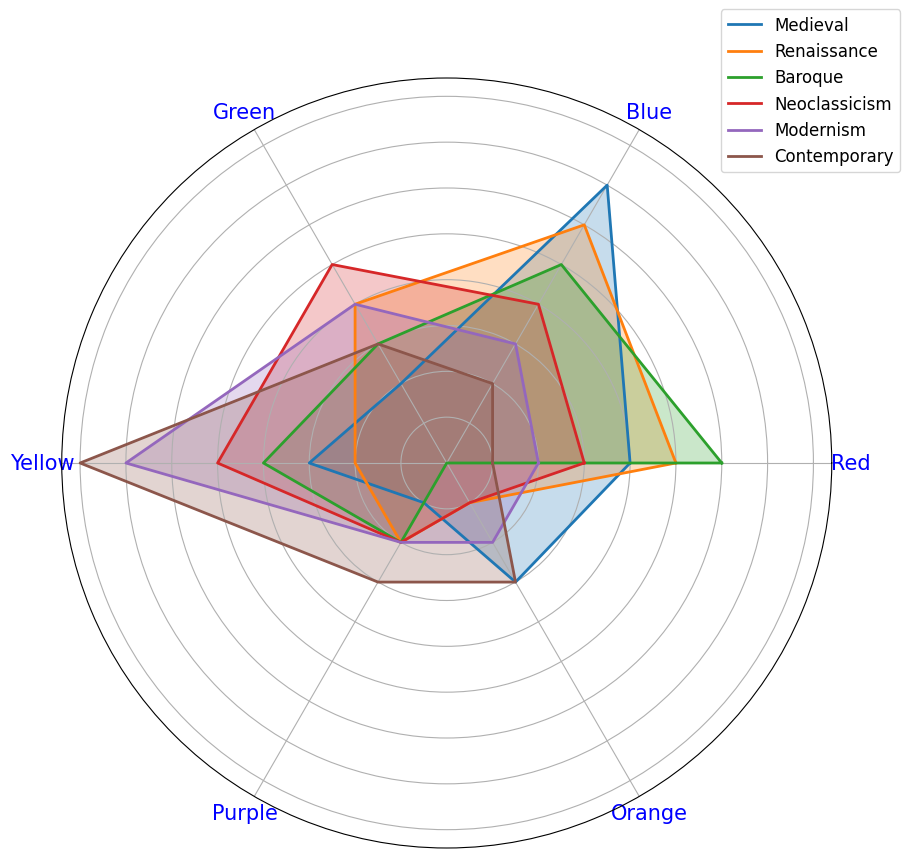Which time period shows the highest usage of yellow? First, look at the yellow values across all time periods. The period with the highest value is the one with the largest length in the yellow section. For yellow, the Contemporary period has the highest value at 40.
Answer: Contemporary Which period has the most balanced usage of all colors? A balanced usage means the plot looks more like a regular polygon. Medieval and Renaissance periods have more balanced-looking shapes, with no color value being extraordinarily high or low.
Answer: Medieval Is the usage of purple increasing or decreasing over time? Observing the radar plot, the purple section remains at a constant value for Medieval to Neoclassicism and increases slightly in the Contemporary period. It is generally stable, then increases.
Answer: Stable then increases Which period has the least use of red? Look for the point on the radar chart corresponding to red for each time period. The Contemporary period has the lowest value for red at 5.
Answer: Contemporary Compare the usage of blue and green during the Renaissance period. Which is higher? Identify the Renaissance period, then compare the lengths of the blue and green sections. Blue is at 30, and green is at 20.
Answer: Blue In which period does green see the highest increase in use compared to the previous period? Look at the green values for each pair of consecutive periods. The largest increase is seen from Renaissance (20) to Neoclassicism (25).
Answer: Neoclassicism How does the usage of orange evolve from Medieval to Contemporary? Evaluate the lengths of the orange section across all periods. Orange starts at 15 in Medieval, drops to 5 in Renaissance, then zero in Baroque, and gradually increases to 15 by Contemporary.
Answer: Declines then increases What is the average usage of red across all periods? Add the red values across all periods and divide by the number of periods. (20 + 25 + 30 + 15 + 10 + 5) / 6 = 17.5
Answer: 17.5 Which period shows the least variability in color usage? Period with least variability will have sections that are more equal in length. The Renaissance and Modernism periods have less variance among their color values.
Answer: Renaissance Compare the usage of yellow in Baroque and Modernism periods. What is the difference? Look at the yellow section for both periods. Baroque is at 20, and Modernism is at 35. The difference is 35 - 20.
Answer: 15 